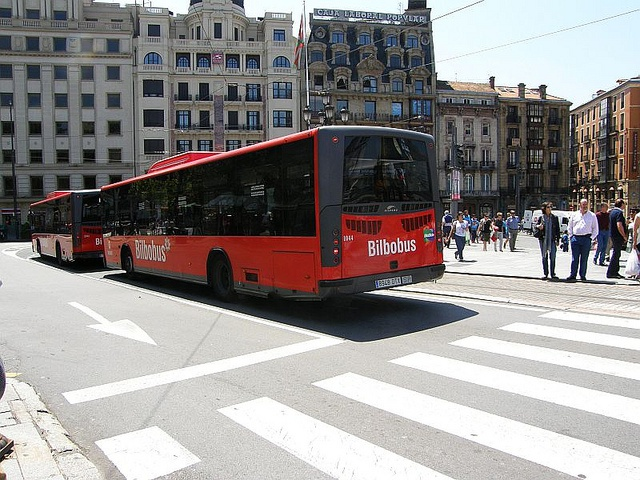Describe the objects in this image and their specific colors. I can see bus in gray, black, brown, and maroon tones, bus in gray, black, maroon, and darkgray tones, people in gray, black, lavender, darkgray, and navy tones, people in gray, black, navy, and lightgray tones, and people in gray, black, navy, and brown tones in this image. 